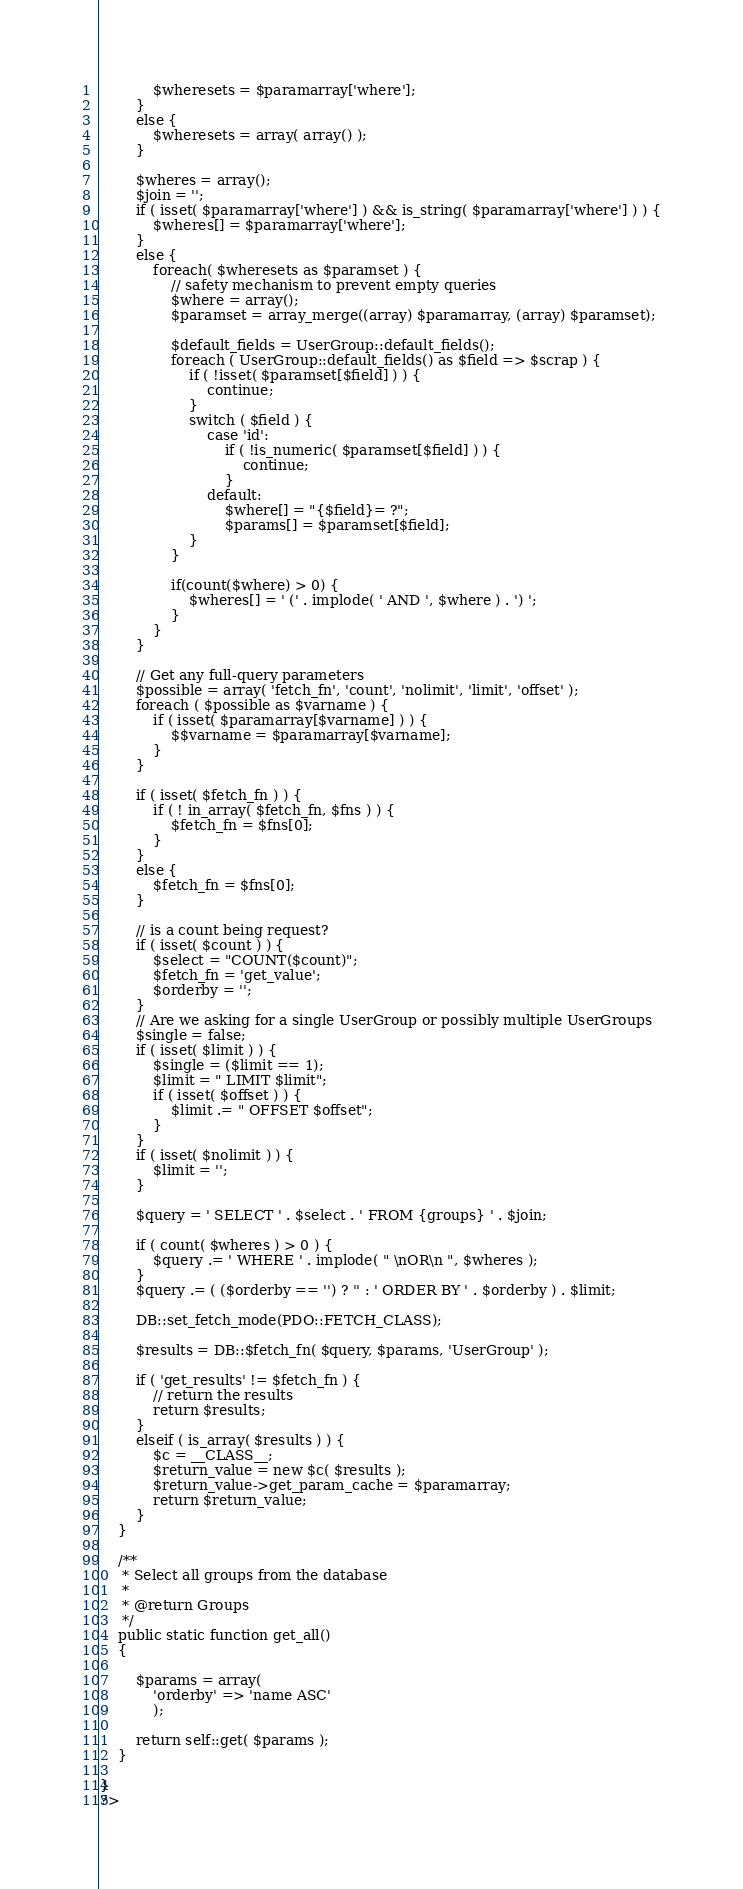<code> <loc_0><loc_0><loc_500><loc_500><_PHP_>			$wheresets = $paramarray['where'];
		}
		else {
			$wheresets = array( array() );
		}

		$wheres = array();
		$join = '';
		if ( isset( $paramarray['where'] ) && is_string( $paramarray['where'] ) ) {
			$wheres[] = $paramarray['where'];
		}
		else {
			foreach( $wheresets as $paramset ) {
				// safety mechanism to prevent empty queries
				$where = array();
				$paramset = array_merge((array) $paramarray, (array) $paramset);
				
				$default_fields = UserGroup::default_fields();
				foreach ( UserGroup::default_fields() as $field => $scrap ) {
					if ( !isset( $paramset[$field] ) ) {
						continue;
					}
					switch ( $field ) {
						case 'id':
							if ( !is_numeric( $paramset[$field] ) ) {
								continue;
							}
						default:
							$where[] = "{$field}= ?";
							$params[] = $paramset[$field];
					}
				}
				
				if(count($where) > 0) {
					$wheres[] = ' (' . implode( ' AND ', $where ) . ') ';
				}
			}
		}

		// Get any full-query parameters
		$possible = array( 'fetch_fn', 'count', 'nolimit', 'limit', 'offset' );
		foreach ( $possible as $varname ) {
			if ( isset( $paramarray[$varname] ) ) {
				$$varname = $paramarray[$varname];
			}
		}

		if ( isset( $fetch_fn ) ) {
			if ( ! in_array( $fetch_fn, $fns ) ) {
				$fetch_fn = $fns[0];
			}
		}
		else {
			$fetch_fn = $fns[0];
		}

		// is a count being request?
		if ( isset( $count ) ) {
			$select = "COUNT($count)";
			$fetch_fn = 'get_value';
			$orderby = '';
		}
		// Are we asking for a single UserGroup or possibly multiple UserGroups
		$single = false;
		if ( isset( $limit ) ) {
			$single = ($limit == 1);
			$limit = " LIMIT $limit";
			if ( isset( $offset ) ) {
				$limit .= " OFFSET $offset";
			}
		}
		if ( isset( $nolimit ) ) {
			$limit = '';
		}

		$query = ' SELECT ' . $select . ' FROM {groups} ' . $join;

		if ( count( $wheres ) > 0 ) {
			$query .= ' WHERE ' . implode( " \nOR\n ", $wheres );
		}
		$query .= ( ($orderby == '') ? '' : ' ORDER BY ' . $orderby ) . $limit;

		DB::set_fetch_mode(PDO::FETCH_CLASS);

		$results = DB::$fetch_fn( $query, $params, 'UserGroup' );

		if ( 'get_results' != $fetch_fn ) {
			// return the results
			return $results;
		}
		elseif ( is_array( $results ) ) {
			$c = __CLASS__;
			$return_value = new $c( $results );
			$return_value->get_param_cache = $paramarray;
			return $return_value;
		}
	}

	/**
	 * Select all groups from the database
	 *
	 * @return Groups
	 */
	public static function get_all()
	{

		$params = array(
			'orderby' => 'name ASC'
			);
			
		return self::get( $params );
	}

}
?>
</code> 